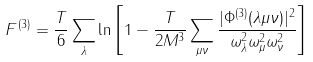Convert formula to latex. <formula><loc_0><loc_0><loc_500><loc_500>F ^ { ( 3 ) } = \frac { T } { 6 } \sum _ { \lambda } \ln \left [ 1 - \frac { T } { 2 M ^ { 3 } } \sum _ { \mu \nu } \frac { | \Phi ^ { ( 3 ) } ( \lambda \mu \nu ) | ^ { 2 } } { \omega _ { \lambda } ^ { 2 } \omega _ { \mu } ^ { 2 } \omega _ { \nu } ^ { 2 } } \right ]</formula> 